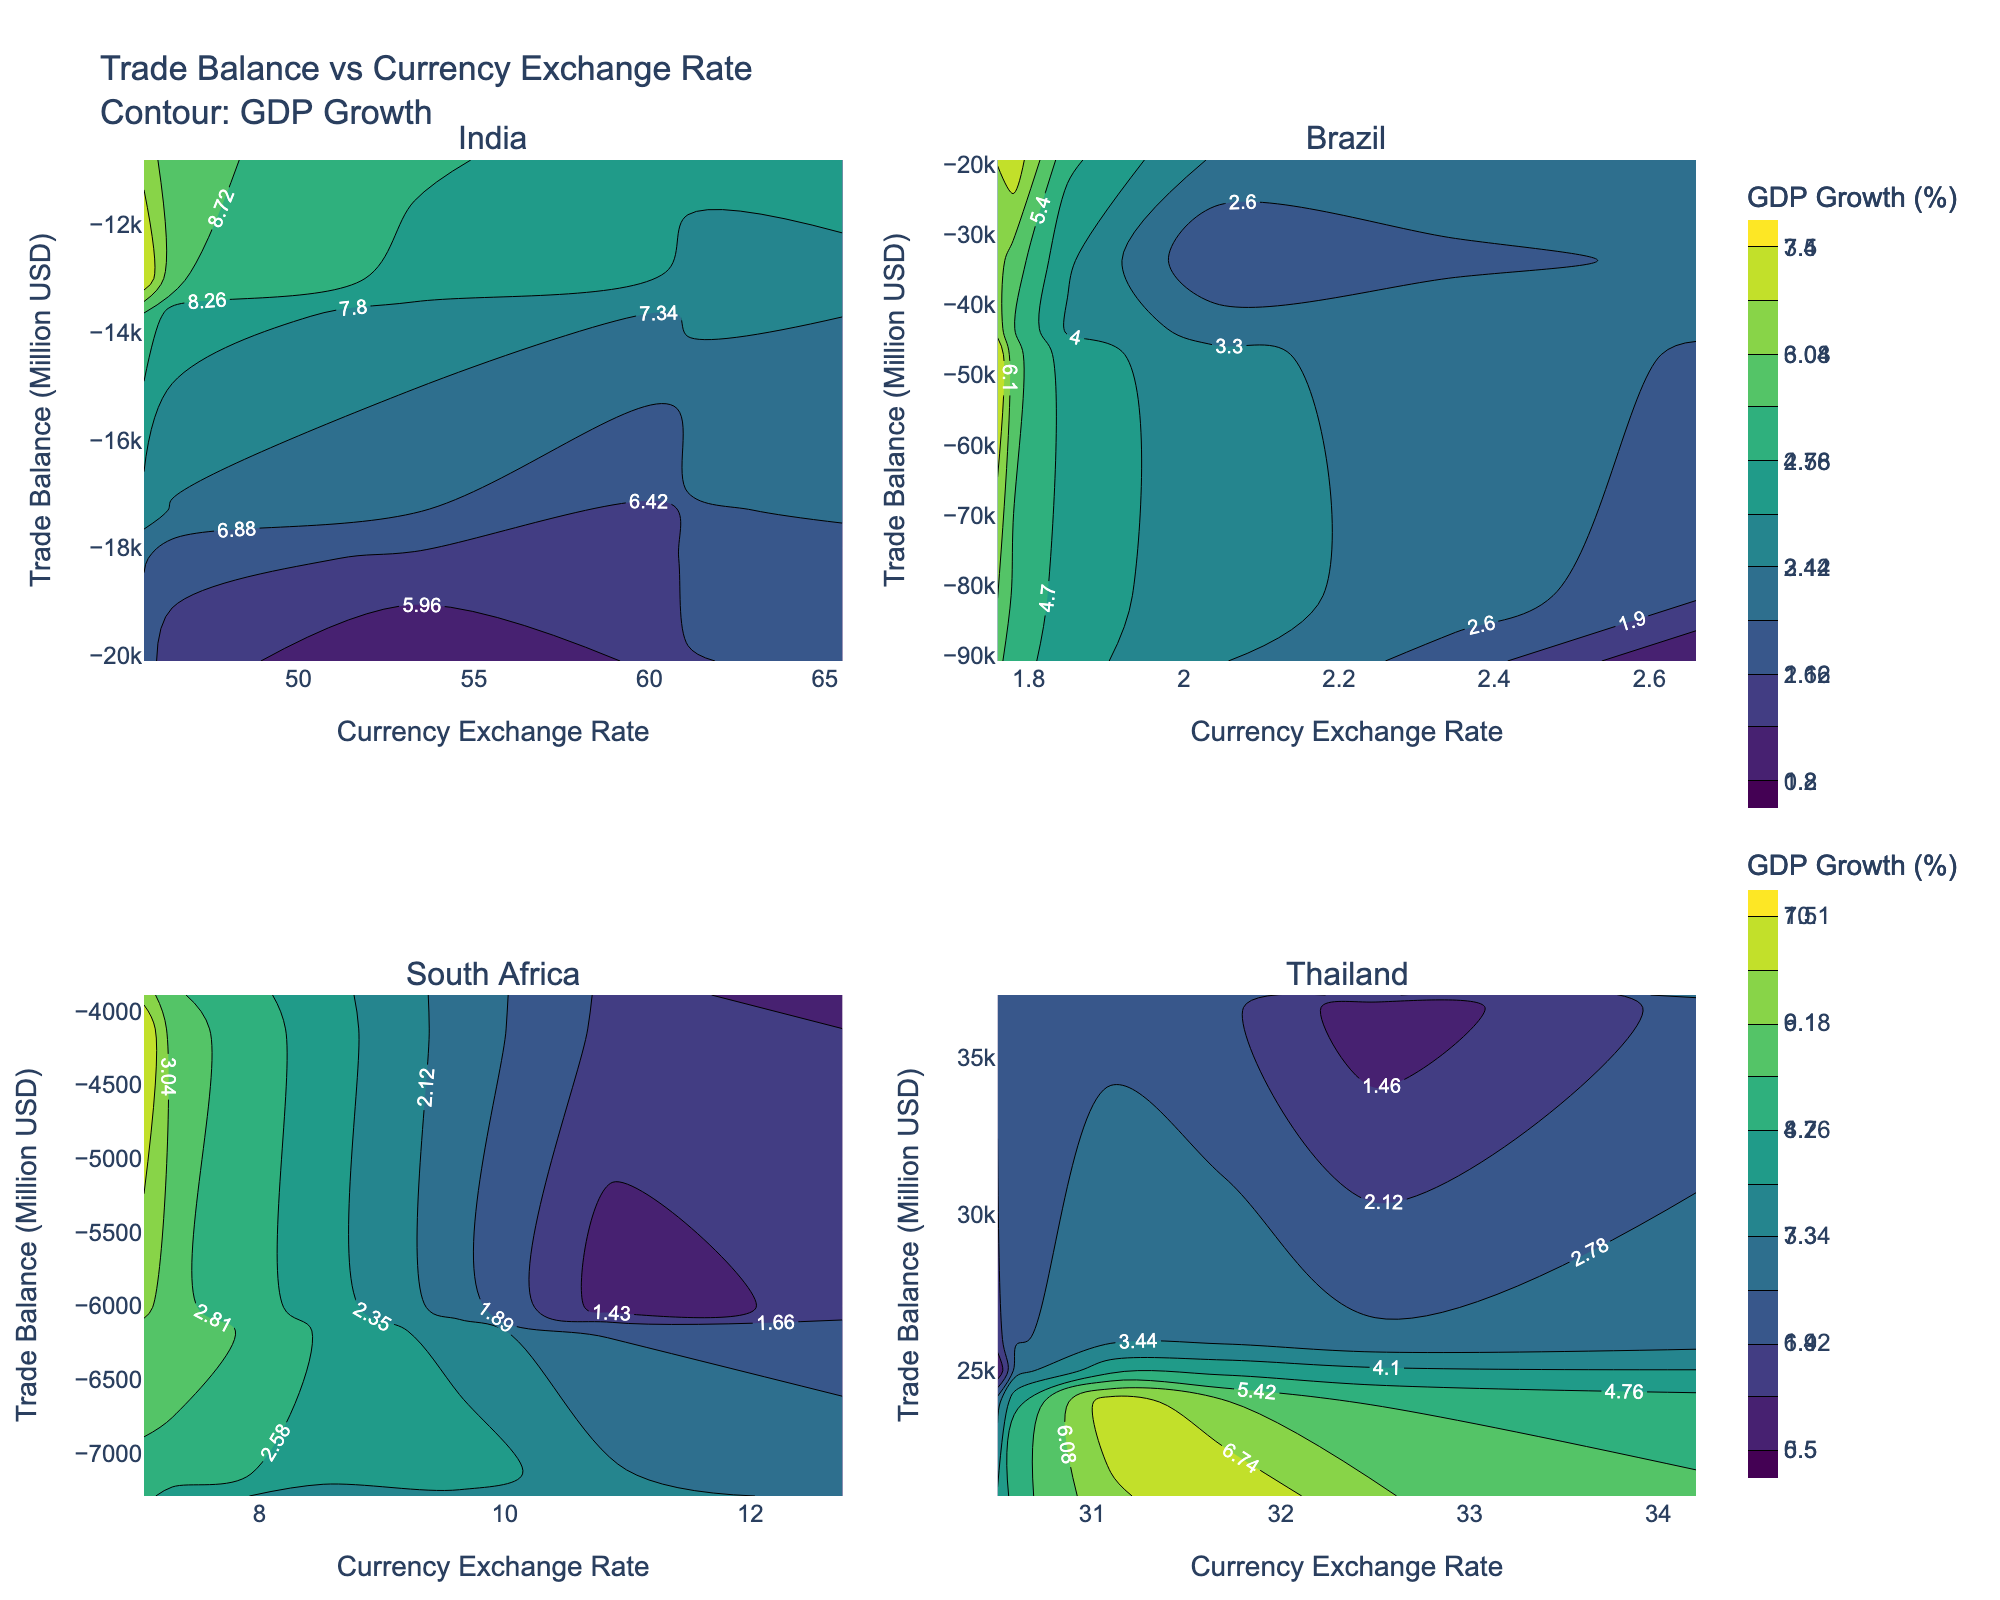What is the title of the figure? The title is generally at the top of the figure and summarizes the data being presented. In this case, it is "Trade Balance vs Currency Exchange Rate Contour: GDP Growth".
Answer: Trade Balance vs Currency Exchange Rate Contour: GDP Growth How many countries are displayed in the subplots? Each subplot represents data for a different country. By counting the subplot titles, we can determine the total number of countries. There are four subplot titles.
Answer: Four Which country shows a positive trade balance across the years? By examining the y-axis (Trade Balance) in each subplot, we observe that only Thailand's subplot consistently shows positive trade balance values.
Answer: Thailand What is the color scale used for visualizing GDP Growth? The color scale used can be identified from the colorbar next to the contours. In this case, the colors range from dark to light using the "Viridis" colorscale.
Answer: Viridis Which country has the highest GDP growth according to the color contour? By examining the contours for all countries, we look for the highest value in the colorbar, and identify the corresponding contours in the subplots. India shows the highest GDP growth at 10.1%.
Answer: India In which year did Brazil have the most negative trade balance, and what was the value? We look at the y-values (Trade Balance) in Brazil's subplot, identify the year with the lowest trade balance, and note the corresponding value. In 2014, Brazil had -90700 million USD.
Answer: 2014, -90700 million USD How does the trade balance vary with respect to the currency exchange rate for South Africa? By following the x-axis (Currency Exchange Rate) and corresponding y-values (Trade Balance), we can observe the trend. The trade balance becomes more negative as the currency exchange rate increases.
Answer: More negative as exchange rate increases Compare the trade balance trends between India and Brazil. By examining the y-axes (Trade Balance) for both India and Brazil, we can observe that both countries show predominantly negative trade balances, but Brazil’s deficits are generally larger than India's.
Answer: Brazil's deficits are larger How does Thailand's trade balance change as the currency exchange rate increases? Observing the relationship in Thailand's subplot, as the currency exchange rate increases, Thailand's trade balance remains positive but shows slight fluctuations.
Answer: Slight fluctuations but remains positive What is the range of GDP growth percentages used for the contour plots? Checking the colorbars for the contours, the minimum and maximum values for GDP growth are specified. The range is from the lowest value (1.0%) to the highest (10.1%).
Answer: 1.0% to 10.1% 